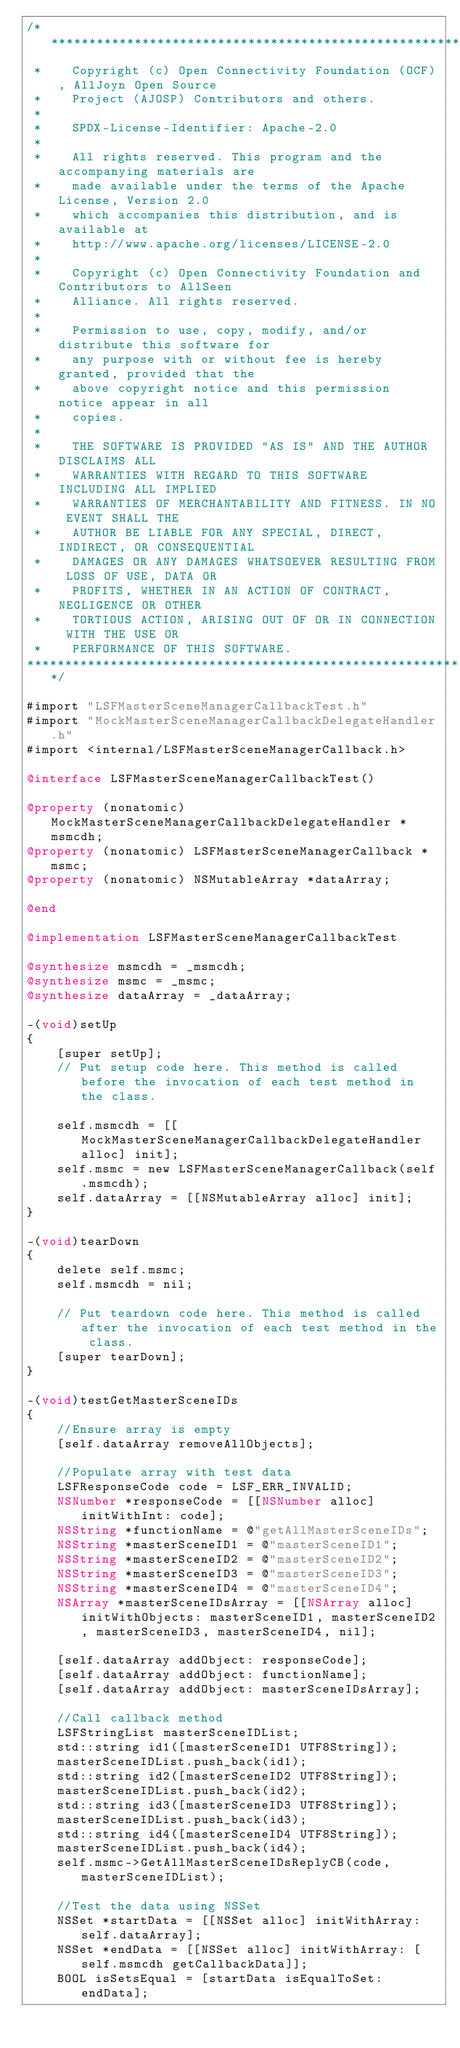Convert code to text. <code><loc_0><loc_0><loc_500><loc_500><_ObjectiveC_>/******************************************************************************
 *    Copyright (c) Open Connectivity Foundation (OCF), AllJoyn Open Source
 *    Project (AJOSP) Contributors and others.
 *    
 *    SPDX-License-Identifier: Apache-2.0
 *    
 *    All rights reserved. This program and the accompanying materials are
 *    made available under the terms of the Apache License, Version 2.0
 *    which accompanies this distribution, and is available at
 *    http://www.apache.org/licenses/LICENSE-2.0
 *    
 *    Copyright (c) Open Connectivity Foundation and Contributors to AllSeen
 *    Alliance. All rights reserved.
 *    
 *    Permission to use, copy, modify, and/or distribute this software for
 *    any purpose with or without fee is hereby granted, provided that the
 *    above copyright notice and this permission notice appear in all
 *    copies.
 *    
 *    THE SOFTWARE IS PROVIDED "AS IS" AND THE AUTHOR DISCLAIMS ALL
 *    WARRANTIES WITH REGARD TO THIS SOFTWARE INCLUDING ALL IMPLIED
 *    WARRANTIES OF MERCHANTABILITY AND FITNESS. IN NO EVENT SHALL THE
 *    AUTHOR BE LIABLE FOR ANY SPECIAL, DIRECT, INDIRECT, OR CONSEQUENTIAL
 *    DAMAGES OR ANY DAMAGES WHATSOEVER RESULTING FROM LOSS OF USE, DATA OR
 *    PROFITS, WHETHER IN AN ACTION OF CONTRACT, NEGLIGENCE OR OTHER
 *    TORTIOUS ACTION, ARISING OUT OF OR IN CONNECTION WITH THE USE OR
 *    PERFORMANCE OF THIS SOFTWARE.
******************************************************************************/

#import "LSFMasterSceneManagerCallbackTest.h"
#import "MockMasterSceneManagerCallbackDelegateHandler.h"
#import <internal/LSFMasterSceneManagerCallback.h>

@interface LSFMasterSceneManagerCallbackTest()

@property (nonatomic) MockMasterSceneManagerCallbackDelegateHandler *msmcdh;
@property (nonatomic) LSFMasterSceneManagerCallback *msmc;
@property (nonatomic) NSMutableArray *dataArray;

@end

@implementation LSFMasterSceneManagerCallbackTest

@synthesize msmcdh = _msmcdh;
@synthesize msmc = _msmc;
@synthesize dataArray = _dataArray;

-(void)setUp
{
    [super setUp];
    // Put setup code here. This method is called before the invocation of each test method in the class.
    
    self.msmcdh = [[MockMasterSceneManagerCallbackDelegateHandler alloc] init];
    self.msmc = new LSFMasterSceneManagerCallback(self.msmcdh);
    self.dataArray = [[NSMutableArray alloc] init];
}

-(void)tearDown
{
    delete self.msmc;
    self.msmcdh = nil;
    
    // Put teardown code here. This method is called after the invocation of each test method in the class.
    [super tearDown];
}

-(void)testGetMasterSceneIDs
{
    //Ensure array is empty
    [self.dataArray removeAllObjects];
    
    //Populate array with test data
    LSFResponseCode code = LSF_ERR_INVALID;
    NSNumber *responseCode = [[NSNumber alloc] initWithInt: code];
    NSString *functionName = @"getAllMasterSceneIDs";
    NSString *masterSceneID1 = @"masterSceneID1";
    NSString *masterSceneID2 = @"masterSceneID2";
    NSString *masterSceneID3 = @"masterSceneID3";
    NSString *masterSceneID4 = @"masterSceneID4";
    NSArray *masterSceneIDsArray = [[NSArray alloc] initWithObjects: masterSceneID1, masterSceneID2, masterSceneID3, masterSceneID4, nil];
    
    [self.dataArray addObject: responseCode];
    [self.dataArray addObject: functionName];
    [self.dataArray addObject: masterSceneIDsArray];
    
    //Call callback method
    LSFStringList masterSceneIDList;
    std::string id1([masterSceneID1 UTF8String]);
    masterSceneIDList.push_back(id1);
    std::string id2([masterSceneID2 UTF8String]);
    masterSceneIDList.push_back(id2);
    std::string id3([masterSceneID3 UTF8String]);
    masterSceneIDList.push_back(id3);
    std::string id4([masterSceneID4 UTF8String]);
    masterSceneIDList.push_back(id4);
    self.msmc->GetAllMasterSceneIDsReplyCB(code, masterSceneIDList);
    
    //Test the data using NSSet
    NSSet *startData = [[NSSet alloc] initWithArray: self.dataArray];
    NSSet *endData = [[NSSet alloc] initWithArray: [self.msmcdh getCallbackData]];
    BOOL isSetsEqual = [startData isEqualToSet: endData];</code> 